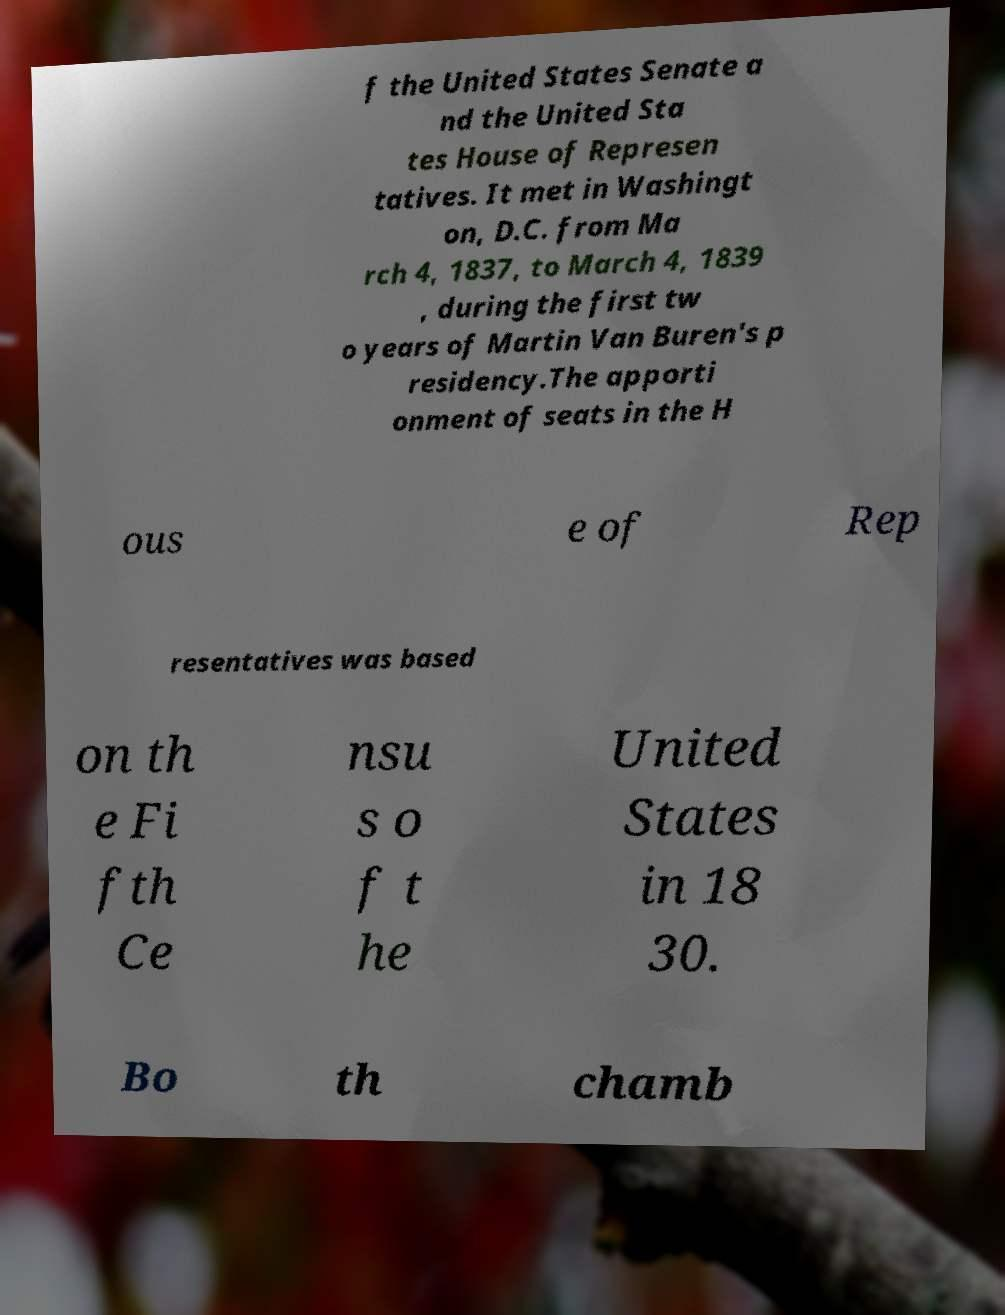I need the written content from this picture converted into text. Can you do that? f the United States Senate a nd the United Sta tes House of Represen tatives. It met in Washingt on, D.C. from Ma rch 4, 1837, to March 4, 1839 , during the first tw o years of Martin Van Buren's p residency.The apporti onment of seats in the H ous e of Rep resentatives was based on th e Fi fth Ce nsu s o f t he United States in 18 30. Bo th chamb 